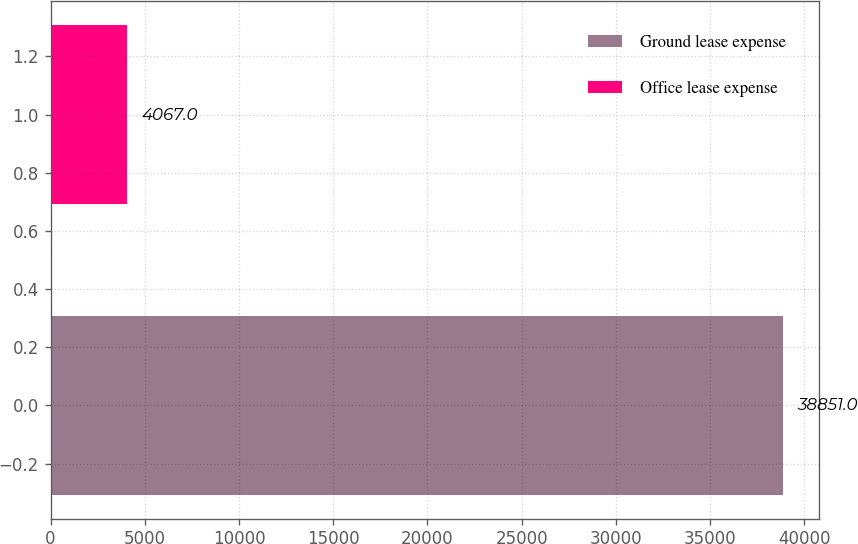<chart> <loc_0><loc_0><loc_500><loc_500><bar_chart><fcel>Ground lease expense<fcel>Office lease expense<nl><fcel>38851<fcel>4067<nl></chart> 